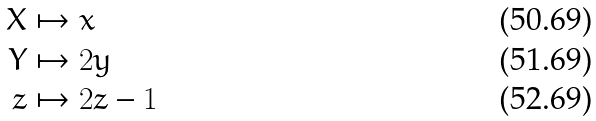<formula> <loc_0><loc_0><loc_500><loc_500>X & \mapsto x \\ Y & \mapsto 2 y \\ z & \mapsto 2 z - 1</formula> 